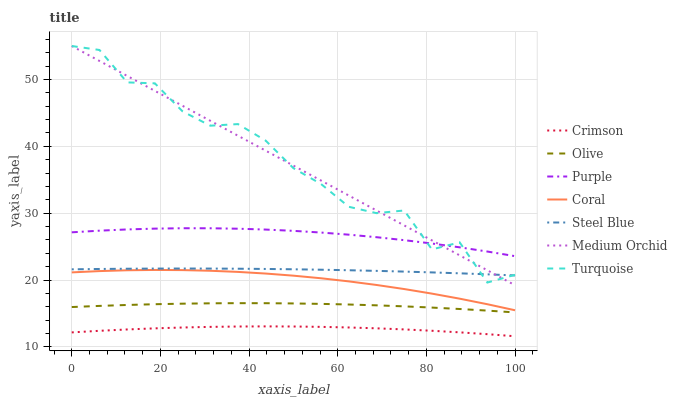Does Crimson have the minimum area under the curve?
Answer yes or no. Yes. Does Turquoise have the maximum area under the curve?
Answer yes or no. Yes. Does Purple have the minimum area under the curve?
Answer yes or no. No. Does Purple have the maximum area under the curve?
Answer yes or no. No. Is Medium Orchid the smoothest?
Answer yes or no. Yes. Is Turquoise the roughest?
Answer yes or no. Yes. Is Purple the smoothest?
Answer yes or no. No. Is Purple the roughest?
Answer yes or no. No. Does Crimson have the lowest value?
Answer yes or no. Yes. Does Coral have the lowest value?
Answer yes or no. No. Does Medium Orchid have the highest value?
Answer yes or no. Yes. Does Purple have the highest value?
Answer yes or no. No. Is Steel Blue less than Purple?
Answer yes or no. Yes. Is Turquoise greater than Olive?
Answer yes or no. Yes. Does Medium Orchid intersect Steel Blue?
Answer yes or no. Yes. Is Medium Orchid less than Steel Blue?
Answer yes or no. No. Is Medium Orchid greater than Steel Blue?
Answer yes or no. No. Does Steel Blue intersect Purple?
Answer yes or no. No. 